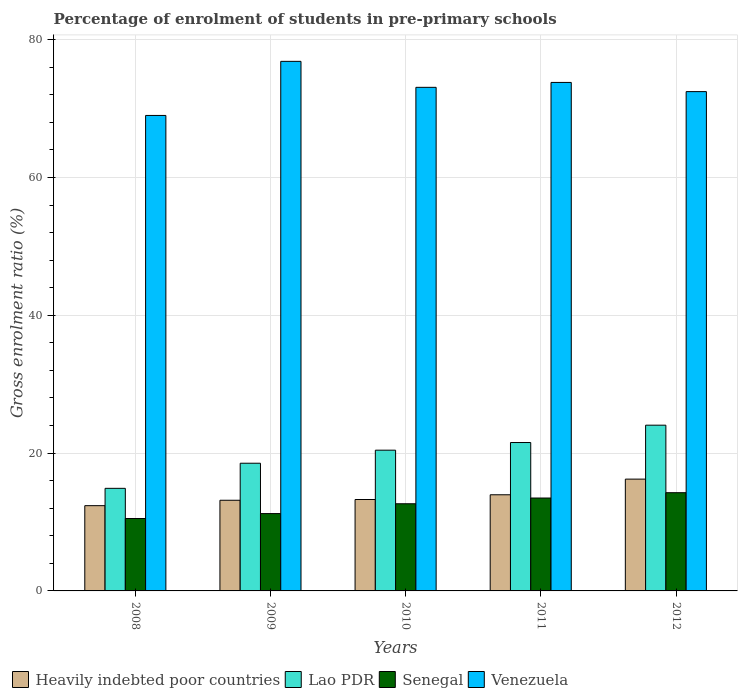How many bars are there on the 3rd tick from the left?
Keep it short and to the point. 4. In how many cases, is the number of bars for a given year not equal to the number of legend labels?
Offer a terse response. 0. What is the percentage of students enrolled in pre-primary schools in Senegal in 2009?
Your answer should be very brief. 11.22. Across all years, what is the maximum percentage of students enrolled in pre-primary schools in Senegal?
Make the answer very short. 14.26. Across all years, what is the minimum percentage of students enrolled in pre-primary schools in Lao PDR?
Offer a terse response. 14.89. What is the total percentage of students enrolled in pre-primary schools in Lao PDR in the graph?
Your answer should be compact. 99.43. What is the difference between the percentage of students enrolled in pre-primary schools in Venezuela in 2009 and that in 2011?
Your answer should be very brief. 3.06. What is the difference between the percentage of students enrolled in pre-primary schools in Heavily indebted poor countries in 2011 and the percentage of students enrolled in pre-primary schools in Senegal in 2012?
Your response must be concise. -0.3. What is the average percentage of students enrolled in pre-primary schools in Venezuela per year?
Provide a short and direct response. 73.04. In the year 2009, what is the difference between the percentage of students enrolled in pre-primary schools in Senegal and percentage of students enrolled in pre-primary schools in Lao PDR?
Your answer should be very brief. -7.31. In how many years, is the percentage of students enrolled in pre-primary schools in Venezuela greater than 8 %?
Offer a very short reply. 5. What is the ratio of the percentage of students enrolled in pre-primary schools in Heavily indebted poor countries in 2009 to that in 2012?
Your answer should be compact. 0.81. Is the percentage of students enrolled in pre-primary schools in Venezuela in 2008 less than that in 2011?
Your answer should be compact. Yes. Is the difference between the percentage of students enrolled in pre-primary schools in Senegal in 2008 and 2012 greater than the difference between the percentage of students enrolled in pre-primary schools in Lao PDR in 2008 and 2012?
Provide a short and direct response. Yes. What is the difference between the highest and the second highest percentage of students enrolled in pre-primary schools in Venezuela?
Make the answer very short. 3.06. What is the difference between the highest and the lowest percentage of students enrolled in pre-primary schools in Senegal?
Give a very brief answer. 3.75. Is the sum of the percentage of students enrolled in pre-primary schools in Senegal in 2008 and 2011 greater than the maximum percentage of students enrolled in pre-primary schools in Venezuela across all years?
Ensure brevity in your answer.  No. What does the 2nd bar from the left in 2010 represents?
Keep it short and to the point. Lao PDR. What does the 1st bar from the right in 2010 represents?
Offer a very short reply. Venezuela. How many bars are there?
Provide a short and direct response. 20. Are all the bars in the graph horizontal?
Your answer should be compact. No. What is the difference between two consecutive major ticks on the Y-axis?
Offer a very short reply. 20. Are the values on the major ticks of Y-axis written in scientific E-notation?
Your response must be concise. No. Does the graph contain any zero values?
Provide a succinct answer. No. Does the graph contain grids?
Make the answer very short. Yes. How are the legend labels stacked?
Provide a succinct answer. Horizontal. What is the title of the graph?
Your answer should be very brief. Percentage of enrolment of students in pre-primary schools. What is the label or title of the X-axis?
Give a very brief answer. Years. What is the label or title of the Y-axis?
Offer a very short reply. Gross enrolment ratio (%). What is the Gross enrolment ratio (%) in Heavily indebted poor countries in 2008?
Offer a very short reply. 12.37. What is the Gross enrolment ratio (%) in Lao PDR in 2008?
Your response must be concise. 14.89. What is the Gross enrolment ratio (%) of Senegal in 2008?
Your response must be concise. 10.51. What is the Gross enrolment ratio (%) of Venezuela in 2008?
Offer a terse response. 69. What is the Gross enrolment ratio (%) of Heavily indebted poor countries in 2009?
Your answer should be very brief. 13.16. What is the Gross enrolment ratio (%) of Lao PDR in 2009?
Your answer should be very brief. 18.53. What is the Gross enrolment ratio (%) in Senegal in 2009?
Keep it short and to the point. 11.22. What is the Gross enrolment ratio (%) in Venezuela in 2009?
Your answer should be compact. 76.85. What is the Gross enrolment ratio (%) of Heavily indebted poor countries in 2010?
Offer a terse response. 13.27. What is the Gross enrolment ratio (%) in Lao PDR in 2010?
Keep it short and to the point. 20.42. What is the Gross enrolment ratio (%) in Senegal in 2010?
Provide a short and direct response. 12.65. What is the Gross enrolment ratio (%) of Venezuela in 2010?
Your answer should be compact. 73.08. What is the Gross enrolment ratio (%) in Heavily indebted poor countries in 2011?
Give a very brief answer. 13.95. What is the Gross enrolment ratio (%) in Lao PDR in 2011?
Provide a short and direct response. 21.54. What is the Gross enrolment ratio (%) of Senegal in 2011?
Your response must be concise. 13.48. What is the Gross enrolment ratio (%) in Venezuela in 2011?
Ensure brevity in your answer.  73.79. What is the Gross enrolment ratio (%) in Heavily indebted poor countries in 2012?
Provide a short and direct response. 16.23. What is the Gross enrolment ratio (%) in Lao PDR in 2012?
Make the answer very short. 24.05. What is the Gross enrolment ratio (%) of Senegal in 2012?
Give a very brief answer. 14.26. What is the Gross enrolment ratio (%) of Venezuela in 2012?
Provide a succinct answer. 72.46. Across all years, what is the maximum Gross enrolment ratio (%) in Heavily indebted poor countries?
Your answer should be very brief. 16.23. Across all years, what is the maximum Gross enrolment ratio (%) of Lao PDR?
Provide a short and direct response. 24.05. Across all years, what is the maximum Gross enrolment ratio (%) of Senegal?
Your answer should be very brief. 14.26. Across all years, what is the maximum Gross enrolment ratio (%) of Venezuela?
Provide a succinct answer. 76.85. Across all years, what is the minimum Gross enrolment ratio (%) in Heavily indebted poor countries?
Your response must be concise. 12.37. Across all years, what is the minimum Gross enrolment ratio (%) in Lao PDR?
Offer a terse response. 14.89. Across all years, what is the minimum Gross enrolment ratio (%) of Senegal?
Provide a succinct answer. 10.51. Across all years, what is the minimum Gross enrolment ratio (%) of Venezuela?
Your response must be concise. 69. What is the total Gross enrolment ratio (%) in Heavily indebted poor countries in the graph?
Your answer should be very brief. 68.97. What is the total Gross enrolment ratio (%) of Lao PDR in the graph?
Make the answer very short. 99.43. What is the total Gross enrolment ratio (%) of Senegal in the graph?
Ensure brevity in your answer.  62.12. What is the total Gross enrolment ratio (%) in Venezuela in the graph?
Make the answer very short. 365.19. What is the difference between the Gross enrolment ratio (%) of Heavily indebted poor countries in 2008 and that in 2009?
Provide a short and direct response. -0.78. What is the difference between the Gross enrolment ratio (%) of Lao PDR in 2008 and that in 2009?
Ensure brevity in your answer.  -3.64. What is the difference between the Gross enrolment ratio (%) in Senegal in 2008 and that in 2009?
Keep it short and to the point. -0.71. What is the difference between the Gross enrolment ratio (%) in Venezuela in 2008 and that in 2009?
Provide a succinct answer. -7.85. What is the difference between the Gross enrolment ratio (%) in Heavily indebted poor countries in 2008 and that in 2010?
Give a very brief answer. -0.89. What is the difference between the Gross enrolment ratio (%) of Lao PDR in 2008 and that in 2010?
Your answer should be very brief. -5.54. What is the difference between the Gross enrolment ratio (%) in Senegal in 2008 and that in 2010?
Provide a short and direct response. -2.14. What is the difference between the Gross enrolment ratio (%) in Venezuela in 2008 and that in 2010?
Offer a very short reply. -4.08. What is the difference between the Gross enrolment ratio (%) in Heavily indebted poor countries in 2008 and that in 2011?
Give a very brief answer. -1.58. What is the difference between the Gross enrolment ratio (%) of Lao PDR in 2008 and that in 2011?
Offer a very short reply. -6.65. What is the difference between the Gross enrolment ratio (%) in Senegal in 2008 and that in 2011?
Offer a terse response. -2.97. What is the difference between the Gross enrolment ratio (%) in Venezuela in 2008 and that in 2011?
Offer a very short reply. -4.79. What is the difference between the Gross enrolment ratio (%) in Heavily indebted poor countries in 2008 and that in 2012?
Make the answer very short. -3.85. What is the difference between the Gross enrolment ratio (%) in Lao PDR in 2008 and that in 2012?
Your response must be concise. -9.17. What is the difference between the Gross enrolment ratio (%) of Senegal in 2008 and that in 2012?
Ensure brevity in your answer.  -3.75. What is the difference between the Gross enrolment ratio (%) in Venezuela in 2008 and that in 2012?
Keep it short and to the point. -3.46. What is the difference between the Gross enrolment ratio (%) in Heavily indebted poor countries in 2009 and that in 2010?
Give a very brief answer. -0.11. What is the difference between the Gross enrolment ratio (%) of Lao PDR in 2009 and that in 2010?
Your answer should be compact. -1.89. What is the difference between the Gross enrolment ratio (%) in Senegal in 2009 and that in 2010?
Make the answer very short. -1.43. What is the difference between the Gross enrolment ratio (%) of Venezuela in 2009 and that in 2010?
Ensure brevity in your answer.  3.77. What is the difference between the Gross enrolment ratio (%) in Heavily indebted poor countries in 2009 and that in 2011?
Make the answer very short. -0.8. What is the difference between the Gross enrolment ratio (%) of Lao PDR in 2009 and that in 2011?
Offer a terse response. -3. What is the difference between the Gross enrolment ratio (%) of Senegal in 2009 and that in 2011?
Make the answer very short. -2.26. What is the difference between the Gross enrolment ratio (%) in Venezuela in 2009 and that in 2011?
Ensure brevity in your answer.  3.06. What is the difference between the Gross enrolment ratio (%) of Heavily indebted poor countries in 2009 and that in 2012?
Offer a terse response. -3.07. What is the difference between the Gross enrolment ratio (%) of Lao PDR in 2009 and that in 2012?
Offer a very short reply. -5.52. What is the difference between the Gross enrolment ratio (%) in Senegal in 2009 and that in 2012?
Ensure brevity in your answer.  -3.03. What is the difference between the Gross enrolment ratio (%) of Venezuela in 2009 and that in 2012?
Offer a very short reply. 4.39. What is the difference between the Gross enrolment ratio (%) of Heavily indebted poor countries in 2010 and that in 2011?
Make the answer very short. -0.69. What is the difference between the Gross enrolment ratio (%) in Lao PDR in 2010 and that in 2011?
Offer a very short reply. -1.11. What is the difference between the Gross enrolment ratio (%) of Senegal in 2010 and that in 2011?
Keep it short and to the point. -0.83. What is the difference between the Gross enrolment ratio (%) of Venezuela in 2010 and that in 2011?
Keep it short and to the point. -0.71. What is the difference between the Gross enrolment ratio (%) of Heavily indebted poor countries in 2010 and that in 2012?
Provide a short and direct response. -2.96. What is the difference between the Gross enrolment ratio (%) in Lao PDR in 2010 and that in 2012?
Offer a very short reply. -3.63. What is the difference between the Gross enrolment ratio (%) in Senegal in 2010 and that in 2012?
Provide a succinct answer. -1.61. What is the difference between the Gross enrolment ratio (%) of Venezuela in 2010 and that in 2012?
Make the answer very short. 0.62. What is the difference between the Gross enrolment ratio (%) of Heavily indebted poor countries in 2011 and that in 2012?
Your answer should be compact. -2.27. What is the difference between the Gross enrolment ratio (%) in Lao PDR in 2011 and that in 2012?
Your answer should be very brief. -2.52. What is the difference between the Gross enrolment ratio (%) of Senegal in 2011 and that in 2012?
Provide a short and direct response. -0.77. What is the difference between the Gross enrolment ratio (%) in Venezuela in 2011 and that in 2012?
Provide a succinct answer. 1.33. What is the difference between the Gross enrolment ratio (%) in Heavily indebted poor countries in 2008 and the Gross enrolment ratio (%) in Lao PDR in 2009?
Your answer should be very brief. -6.16. What is the difference between the Gross enrolment ratio (%) in Heavily indebted poor countries in 2008 and the Gross enrolment ratio (%) in Senegal in 2009?
Keep it short and to the point. 1.15. What is the difference between the Gross enrolment ratio (%) in Heavily indebted poor countries in 2008 and the Gross enrolment ratio (%) in Venezuela in 2009?
Give a very brief answer. -64.48. What is the difference between the Gross enrolment ratio (%) in Lao PDR in 2008 and the Gross enrolment ratio (%) in Senegal in 2009?
Provide a short and direct response. 3.66. What is the difference between the Gross enrolment ratio (%) of Lao PDR in 2008 and the Gross enrolment ratio (%) of Venezuela in 2009?
Give a very brief answer. -61.97. What is the difference between the Gross enrolment ratio (%) of Senegal in 2008 and the Gross enrolment ratio (%) of Venezuela in 2009?
Make the answer very short. -66.34. What is the difference between the Gross enrolment ratio (%) in Heavily indebted poor countries in 2008 and the Gross enrolment ratio (%) in Lao PDR in 2010?
Your answer should be compact. -8.05. What is the difference between the Gross enrolment ratio (%) in Heavily indebted poor countries in 2008 and the Gross enrolment ratio (%) in Senegal in 2010?
Your answer should be very brief. -0.28. What is the difference between the Gross enrolment ratio (%) of Heavily indebted poor countries in 2008 and the Gross enrolment ratio (%) of Venezuela in 2010?
Provide a succinct answer. -60.71. What is the difference between the Gross enrolment ratio (%) of Lao PDR in 2008 and the Gross enrolment ratio (%) of Senegal in 2010?
Offer a terse response. 2.24. What is the difference between the Gross enrolment ratio (%) in Lao PDR in 2008 and the Gross enrolment ratio (%) in Venezuela in 2010?
Keep it short and to the point. -58.19. What is the difference between the Gross enrolment ratio (%) of Senegal in 2008 and the Gross enrolment ratio (%) of Venezuela in 2010?
Your answer should be compact. -62.57. What is the difference between the Gross enrolment ratio (%) of Heavily indebted poor countries in 2008 and the Gross enrolment ratio (%) of Lao PDR in 2011?
Give a very brief answer. -9.16. What is the difference between the Gross enrolment ratio (%) of Heavily indebted poor countries in 2008 and the Gross enrolment ratio (%) of Senegal in 2011?
Make the answer very short. -1.11. What is the difference between the Gross enrolment ratio (%) of Heavily indebted poor countries in 2008 and the Gross enrolment ratio (%) of Venezuela in 2011?
Provide a succinct answer. -61.42. What is the difference between the Gross enrolment ratio (%) of Lao PDR in 2008 and the Gross enrolment ratio (%) of Senegal in 2011?
Keep it short and to the point. 1.4. What is the difference between the Gross enrolment ratio (%) of Lao PDR in 2008 and the Gross enrolment ratio (%) of Venezuela in 2011?
Make the answer very short. -58.91. What is the difference between the Gross enrolment ratio (%) in Senegal in 2008 and the Gross enrolment ratio (%) in Venezuela in 2011?
Your answer should be very brief. -63.29. What is the difference between the Gross enrolment ratio (%) in Heavily indebted poor countries in 2008 and the Gross enrolment ratio (%) in Lao PDR in 2012?
Your answer should be very brief. -11.68. What is the difference between the Gross enrolment ratio (%) of Heavily indebted poor countries in 2008 and the Gross enrolment ratio (%) of Senegal in 2012?
Your answer should be very brief. -1.88. What is the difference between the Gross enrolment ratio (%) of Heavily indebted poor countries in 2008 and the Gross enrolment ratio (%) of Venezuela in 2012?
Your answer should be very brief. -60.09. What is the difference between the Gross enrolment ratio (%) of Lao PDR in 2008 and the Gross enrolment ratio (%) of Senegal in 2012?
Provide a short and direct response. 0.63. What is the difference between the Gross enrolment ratio (%) of Lao PDR in 2008 and the Gross enrolment ratio (%) of Venezuela in 2012?
Keep it short and to the point. -57.57. What is the difference between the Gross enrolment ratio (%) of Senegal in 2008 and the Gross enrolment ratio (%) of Venezuela in 2012?
Offer a very short reply. -61.95. What is the difference between the Gross enrolment ratio (%) in Heavily indebted poor countries in 2009 and the Gross enrolment ratio (%) in Lao PDR in 2010?
Your answer should be very brief. -7.27. What is the difference between the Gross enrolment ratio (%) of Heavily indebted poor countries in 2009 and the Gross enrolment ratio (%) of Senegal in 2010?
Make the answer very short. 0.51. What is the difference between the Gross enrolment ratio (%) in Heavily indebted poor countries in 2009 and the Gross enrolment ratio (%) in Venezuela in 2010?
Your response must be concise. -59.92. What is the difference between the Gross enrolment ratio (%) of Lao PDR in 2009 and the Gross enrolment ratio (%) of Senegal in 2010?
Offer a very short reply. 5.88. What is the difference between the Gross enrolment ratio (%) in Lao PDR in 2009 and the Gross enrolment ratio (%) in Venezuela in 2010?
Your answer should be compact. -54.55. What is the difference between the Gross enrolment ratio (%) of Senegal in 2009 and the Gross enrolment ratio (%) of Venezuela in 2010?
Provide a succinct answer. -61.86. What is the difference between the Gross enrolment ratio (%) in Heavily indebted poor countries in 2009 and the Gross enrolment ratio (%) in Lao PDR in 2011?
Keep it short and to the point. -8.38. What is the difference between the Gross enrolment ratio (%) in Heavily indebted poor countries in 2009 and the Gross enrolment ratio (%) in Senegal in 2011?
Your response must be concise. -0.33. What is the difference between the Gross enrolment ratio (%) of Heavily indebted poor countries in 2009 and the Gross enrolment ratio (%) of Venezuela in 2011?
Provide a succinct answer. -60.64. What is the difference between the Gross enrolment ratio (%) of Lao PDR in 2009 and the Gross enrolment ratio (%) of Senegal in 2011?
Keep it short and to the point. 5.05. What is the difference between the Gross enrolment ratio (%) of Lao PDR in 2009 and the Gross enrolment ratio (%) of Venezuela in 2011?
Make the answer very short. -55.26. What is the difference between the Gross enrolment ratio (%) in Senegal in 2009 and the Gross enrolment ratio (%) in Venezuela in 2011?
Your response must be concise. -62.57. What is the difference between the Gross enrolment ratio (%) in Heavily indebted poor countries in 2009 and the Gross enrolment ratio (%) in Lao PDR in 2012?
Ensure brevity in your answer.  -10.9. What is the difference between the Gross enrolment ratio (%) of Heavily indebted poor countries in 2009 and the Gross enrolment ratio (%) of Senegal in 2012?
Keep it short and to the point. -1.1. What is the difference between the Gross enrolment ratio (%) of Heavily indebted poor countries in 2009 and the Gross enrolment ratio (%) of Venezuela in 2012?
Give a very brief answer. -59.3. What is the difference between the Gross enrolment ratio (%) in Lao PDR in 2009 and the Gross enrolment ratio (%) in Senegal in 2012?
Ensure brevity in your answer.  4.28. What is the difference between the Gross enrolment ratio (%) in Lao PDR in 2009 and the Gross enrolment ratio (%) in Venezuela in 2012?
Provide a short and direct response. -53.93. What is the difference between the Gross enrolment ratio (%) in Senegal in 2009 and the Gross enrolment ratio (%) in Venezuela in 2012?
Keep it short and to the point. -61.24. What is the difference between the Gross enrolment ratio (%) of Heavily indebted poor countries in 2010 and the Gross enrolment ratio (%) of Lao PDR in 2011?
Your response must be concise. -8.27. What is the difference between the Gross enrolment ratio (%) in Heavily indebted poor countries in 2010 and the Gross enrolment ratio (%) in Senegal in 2011?
Make the answer very short. -0.22. What is the difference between the Gross enrolment ratio (%) in Heavily indebted poor countries in 2010 and the Gross enrolment ratio (%) in Venezuela in 2011?
Offer a terse response. -60.53. What is the difference between the Gross enrolment ratio (%) of Lao PDR in 2010 and the Gross enrolment ratio (%) of Senegal in 2011?
Provide a succinct answer. 6.94. What is the difference between the Gross enrolment ratio (%) in Lao PDR in 2010 and the Gross enrolment ratio (%) in Venezuela in 2011?
Offer a very short reply. -53.37. What is the difference between the Gross enrolment ratio (%) of Senegal in 2010 and the Gross enrolment ratio (%) of Venezuela in 2011?
Keep it short and to the point. -61.14. What is the difference between the Gross enrolment ratio (%) of Heavily indebted poor countries in 2010 and the Gross enrolment ratio (%) of Lao PDR in 2012?
Make the answer very short. -10.79. What is the difference between the Gross enrolment ratio (%) of Heavily indebted poor countries in 2010 and the Gross enrolment ratio (%) of Senegal in 2012?
Your answer should be compact. -0.99. What is the difference between the Gross enrolment ratio (%) of Heavily indebted poor countries in 2010 and the Gross enrolment ratio (%) of Venezuela in 2012?
Your response must be concise. -59.19. What is the difference between the Gross enrolment ratio (%) in Lao PDR in 2010 and the Gross enrolment ratio (%) in Senegal in 2012?
Your answer should be compact. 6.17. What is the difference between the Gross enrolment ratio (%) of Lao PDR in 2010 and the Gross enrolment ratio (%) of Venezuela in 2012?
Your answer should be compact. -52.04. What is the difference between the Gross enrolment ratio (%) of Senegal in 2010 and the Gross enrolment ratio (%) of Venezuela in 2012?
Your answer should be very brief. -59.81. What is the difference between the Gross enrolment ratio (%) of Heavily indebted poor countries in 2011 and the Gross enrolment ratio (%) of Lao PDR in 2012?
Provide a succinct answer. -10.1. What is the difference between the Gross enrolment ratio (%) in Heavily indebted poor countries in 2011 and the Gross enrolment ratio (%) in Senegal in 2012?
Ensure brevity in your answer.  -0.3. What is the difference between the Gross enrolment ratio (%) of Heavily indebted poor countries in 2011 and the Gross enrolment ratio (%) of Venezuela in 2012?
Give a very brief answer. -58.51. What is the difference between the Gross enrolment ratio (%) of Lao PDR in 2011 and the Gross enrolment ratio (%) of Senegal in 2012?
Your answer should be very brief. 7.28. What is the difference between the Gross enrolment ratio (%) of Lao PDR in 2011 and the Gross enrolment ratio (%) of Venezuela in 2012?
Make the answer very short. -50.93. What is the difference between the Gross enrolment ratio (%) in Senegal in 2011 and the Gross enrolment ratio (%) in Venezuela in 2012?
Offer a terse response. -58.98. What is the average Gross enrolment ratio (%) of Heavily indebted poor countries per year?
Offer a very short reply. 13.79. What is the average Gross enrolment ratio (%) in Lao PDR per year?
Provide a short and direct response. 19.89. What is the average Gross enrolment ratio (%) in Senegal per year?
Give a very brief answer. 12.42. What is the average Gross enrolment ratio (%) in Venezuela per year?
Give a very brief answer. 73.04. In the year 2008, what is the difference between the Gross enrolment ratio (%) in Heavily indebted poor countries and Gross enrolment ratio (%) in Lao PDR?
Offer a very short reply. -2.51. In the year 2008, what is the difference between the Gross enrolment ratio (%) of Heavily indebted poor countries and Gross enrolment ratio (%) of Senegal?
Your response must be concise. 1.86. In the year 2008, what is the difference between the Gross enrolment ratio (%) in Heavily indebted poor countries and Gross enrolment ratio (%) in Venezuela?
Provide a succinct answer. -56.63. In the year 2008, what is the difference between the Gross enrolment ratio (%) of Lao PDR and Gross enrolment ratio (%) of Senegal?
Give a very brief answer. 4.38. In the year 2008, what is the difference between the Gross enrolment ratio (%) in Lao PDR and Gross enrolment ratio (%) in Venezuela?
Your answer should be compact. -54.12. In the year 2008, what is the difference between the Gross enrolment ratio (%) in Senegal and Gross enrolment ratio (%) in Venezuela?
Your answer should be very brief. -58.49. In the year 2009, what is the difference between the Gross enrolment ratio (%) in Heavily indebted poor countries and Gross enrolment ratio (%) in Lao PDR?
Your answer should be very brief. -5.37. In the year 2009, what is the difference between the Gross enrolment ratio (%) in Heavily indebted poor countries and Gross enrolment ratio (%) in Senegal?
Ensure brevity in your answer.  1.93. In the year 2009, what is the difference between the Gross enrolment ratio (%) of Heavily indebted poor countries and Gross enrolment ratio (%) of Venezuela?
Make the answer very short. -63.7. In the year 2009, what is the difference between the Gross enrolment ratio (%) in Lao PDR and Gross enrolment ratio (%) in Senegal?
Your answer should be compact. 7.31. In the year 2009, what is the difference between the Gross enrolment ratio (%) of Lao PDR and Gross enrolment ratio (%) of Venezuela?
Offer a terse response. -58.32. In the year 2009, what is the difference between the Gross enrolment ratio (%) of Senegal and Gross enrolment ratio (%) of Venezuela?
Keep it short and to the point. -65.63. In the year 2010, what is the difference between the Gross enrolment ratio (%) in Heavily indebted poor countries and Gross enrolment ratio (%) in Lao PDR?
Make the answer very short. -7.16. In the year 2010, what is the difference between the Gross enrolment ratio (%) in Heavily indebted poor countries and Gross enrolment ratio (%) in Senegal?
Provide a succinct answer. 0.62. In the year 2010, what is the difference between the Gross enrolment ratio (%) in Heavily indebted poor countries and Gross enrolment ratio (%) in Venezuela?
Give a very brief answer. -59.81. In the year 2010, what is the difference between the Gross enrolment ratio (%) of Lao PDR and Gross enrolment ratio (%) of Senegal?
Ensure brevity in your answer.  7.77. In the year 2010, what is the difference between the Gross enrolment ratio (%) of Lao PDR and Gross enrolment ratio (%) of Venezuela?
Your answer should be very brief. -52.66. In the year 2010, what is the difference between the Gross enrolment ratio (%) of Senegal and Gross enrolment ratio (%) of Venezuela?
Your answer should be compact. -60.43. In the year 2011, what is the difference between the Gross enrolment ratio (%) of Heavily indebted poor countries and Gross enrolment ratio (%) of Lao PDR?
Your answer should be very brief. -7.58. In the year 2011, what is the difference between the Gross enrolment ratio (%) in Heavily indebted poor countries and Gross enrolment ratio (%) in Senegal?
Make the answer very short. 0.47. In the year 2011, what is the difference between the Gross enrolment ratio (%) of Heavily indebted poor countries and Gross enrolment ratio (%) of Venezuela?
Ensure brevity in your answer.  -59.84. In the year 2011, what is the difference between the Gross enrolment ratio (%) in Lao PDR and Gross enrolment ratio (%) in Senegal?
Offer a terse response. 8.05. In the year 2011, what is the difference between the Gross enrolment ratio (%) of Lao PDR and Gross enrolment ratio (%) of Venezuela?
Give a very brief answer. -52.26. In the year 2011, what is the difference between the Gross enrolment ratio (%) in Senegal and Gross enrolment ratio (%) in Venezuela?
Give a very brief answer. -60.31. In the year 2012, what is the difference between the Gross enrolment ratio (%) in Heavily indebted poor countries and Gross enrolment ratio (%) in Lao PDR?
Your answer should be compact. -7.83. In the year 2012, what is the difference between the Gross enrolment ratio (%) of Heavily indebted poor countries and Gross enrolment ratio (%) of Senegal?
Provide a succinct answer. 1.97. In the year 2012, what is the difference between the Gross enrolment ratio (%) of Heavily indebted poor countries and Gross enrolment ratio (%) of Venezuela?
Your answer should be very brief. -56.24. In the year 2012, what is the difference between the Gross enrolment ratio (%) in Lao PDR and Gross enrolment ratio (%) in Senegal?
Offer a very short reply. 9.8. In the year 2012, what is the difference between the Gross enrolment ratio (%) in Lao PDR and Gross enrolment ratio (%) in Venezuela?
Your response must be concise. -48.41. In the year 2012, what is the difference between the Gross enrolment ratio (%) of Senegal and Gross enrolment ratio (%) of Venezuela?
Ensure brevity in your answer.  -58.21. What is the ratio of the Gross enrolment ratio (%) of Heavily indebted poor countries in 2008 to that in 2009?
Make the answer very short. 0.94. What is the ratio of the Gross enrolment ratio (%) of Lao PDR in 2008 to that in 2009?
Your response must be concise. 0.8. What is the ratio of the Gross enrolment ratio (%) of Senegal in 2008 to that in 2009?
Your answer should be compact. 0.94. What is the ratio of the Gross enrolment ratio (%) in Venezuela in 2008 to that in 2009?
Your response must be concise. 0.9. What is the ratio of the Gross enrolment ratio (%) in Heavily indebted poor countries in 2008 to that in 2010?
Offer a very short reply. 0.93. What is the ratio of the Gross enrolment ratio (%) of Lao PDR in 2008 to that in 2010?
Give a very brief answer. 0.73. What is the ratio of the Gross enrolment ratio (%) of Senegal in 2008 to that in 2010?
Make the answer very short. 0.83. What is the ratio of the Gross enrolment ratio (%) in Venezuela in 2008 to that in 2010?
Provide a short and direct response. 0.94. What is the ratio of the Gross enrolment ratio (%) in Heavily indebted poor countries in 2008 to that in 2011?
Ensure brevity in your answer.  0.89. What is the ratio of the Gross enrolment ratio (%) of Lao PDR in 2008 to that in 2011?
Give a very brief answer. 0.69. What is the ratio of the Gross enrolment ratio (%) of Senegal in 2008 to that in 2011?
Provide a succinct answer. 0.78. What is the ratio of the Gross enrolment ratio (%) of Venezuela in 2008 to that in 2011?
Keep it short and to the point. 0.94. What is the ratio of the Gross enrolment ratio (%) in Heavily indebted poor countries in 2008 to that in 2012?
Your answer should be compact. 0.76. What is the ratio of the Gross enrolment ratio (%) of Lao PDR in 2008 to that in 2012?
Offer a terse response. 0.62. What is the ratio of the Gross enrolment ratio (%) of Senegal in 2008 to that in 2012?
Offer a terse response. 0.74. What is the ratio of the Gross enrolment ratio (%) of Venezuela in 2008 to that in 2012?
Make the answer very short. 0.95. What is the ratio of the Gross enrolment ratio (%) of Lao PDR in 2009 to that in 2010?
Keep it short and to the point. 0.91. What is the ratio of the Gross enrolment ratio (%) in Senegal in 2009 to that in 2010?
Provide a succinct answer. 0.89. What is the ratio of the Gross enrolment ratio (%) in Venezuela in 2009 to that in 2010?
Your answer should be very brief. 1.05. What is the ratio of the Gross enrolment ratio (%) of Heavily indebted poor countries in 2009 to that in 2011?
Offer a terse response. 0.94. What is the ratio of the Gross enrolment ratio (%) of Lao PDR in 2009 to that in 2011?
Keep it short and to the point. 0.86. What is the ratio of the Gross enrolment ratio (%) in Senegal in 2009 to that in 2011?
Ensure brevity in your answer.  0.83. What is the ratio of the Gross enrolment ratio (%) in Venezuela in 2009 to that in 2011?
Ensure brevity in your answer.  1.04. What is the ratio of the Gross enrolment ratio (%) of Heavily indebted poor countries in 2009 to that in 2012?
Provide a succinct answer. 0.81. What is the ratio of the Gross enrolment ratio (%) of Lao PDR in 2009 to that in 2012?
Provide a short and direct response. 0.77. What is the ratio of the Gross enrolment ratio (%) in Senegal in 2009 to that in 2012?
Your answer should be compact. 0.79. What is the ratio of the Gross enrolment ratio (%) in Venezuela in 2009 to that in 2012?
Your response must be concise. 1.06. What is the ratio of the Gross enrolment ratio (%) of Heavily indebted poor countries in 2010 to that in 2011?
Offer a very short reply. 0.95. What is the ratio of the Gross enrolment ratio (%) in Lao PDR in 2010 to that in 2011?
Keep it short and to the point. 0.95. What is the ratio of the Gross enrolment ratio (%) of Senegal in 2010 to that in 2011?
Ensure brevity in your answer.  0.94. What is the ratio of the Gross enrolment ratio (%) in Venezuela in 2010 to that in 2011?
Offer a terse response. 0.99. What is the ratio of the Gross enrolment ratio (%) of Heavily indebted poor countries in 2010 to that in 2012?
Keep it short and to the point. 0.82. What is the ratio of the Gross enrolment ratio (%) in Lao PDR in 2010 to that in 2012?
Make the answer very short. 0.85. What is the ratio of the Gross enrolment ratio (%) of Senegal in 2010 to that in 2012?
Provide a short and direct response. 0.89. What is the ratio of the Gross enrolment ratio (%) in Venezuela in 2010 to that in 2012?
Give a very brief answer. 1.01. What is the ratio of the Gross enrolment ratio (%) in Heavily indebted poor countries in 2011 to that in 2012?
Keep it short and to the point. 0.86. What is the ratio of the Gross enrolment ratio (%) of Lao PDR in 2011 to that in 2012?
Your answer should be compact. 0.9. What is the ratio of the Gross enrolment ratio (%) of Senegal in 2011 to that in 2012?
Provide a short and direct response. 0.95. What is the ratio of the Gross enrolment ratio (%) of Venezuela in 2011 to that in 2012?
Provide a short and direct response. 1.02. What is the difference between the highest and the second highest Gross enrolment ratio (%) of Heavily indebted poor countries?
Offer a very short reply. 2.27. What is the difference between the highest and the second highest Gross enrolment ratio (%) in Lao PDR?
Your response must be concise. 2.52. What is the difference between the highest and the second highest Gross enrolment ratio (%) in Senegal?
Your answer should be very brief. 0.77. What is the difference between the highest and the second highest Gross enrolment ratio (%) in Venezuela?
Offer a terse response. 3.06. What is the difference between the highest and the lowest Gross enrolment ratio (%) in Heavily indebted poor countries?
Make the answer very short. 3.85. What is the difference between the highest and the lowest Gross enrolment ratio (%) in Lao PDR?
Offer a terse response. 9.17. What is the difference between the highest and the lowest Gross enrolment ratio (%) in Senegal?
Your answer should be very brief. 3.75. What is the difference between the highest and the lowest Gross enrolment ratio (%) of Venezuela?
Offer a terse response. 7.85. 